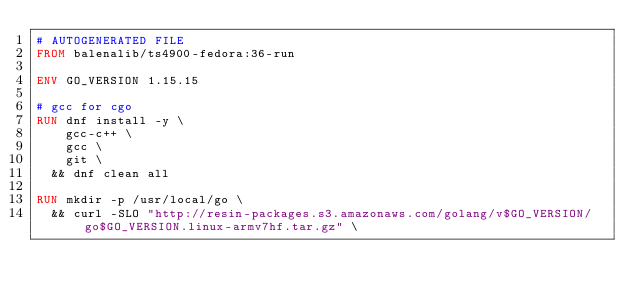<code> <loc_0><loc_0><loc_500><loc_500><_Dockerfile_># AUTOGENERATED FILE
FROM balenalib/ts4900-fedora:36-run

ENV GO_VERSION 1.15.15

# gcc for cgo
RUN dnf install -y \
		gcc-c++ \
		gcc \
		git \
	&& dnf clean all

RUN mkdir -p /usr/local/go \
	&& curl -SLO "http://resin-packages.s3.amazonaws.com/golang/v$GO_VERSION/go$GO_VERSION.linux-armv7hf.tar.gz" \</code> 